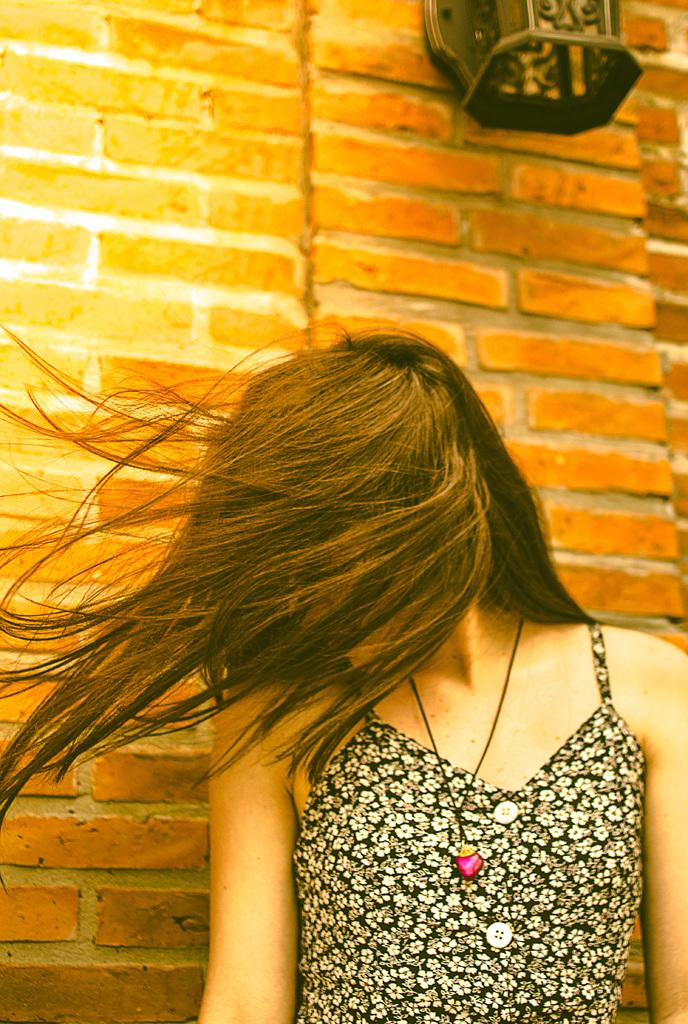Who is present in the image? There is a woman in the image. What is covering the woman's face? The woman's face is covered with her hair. What can be seen in the background of the image? There is an object on the wall in the background of the image. What type of muscle is visible on the woman's arm in the image? There is no muscle visible on the woman's arm in the image, as her face is covered with her hair and no other body parts are clearly visible. 